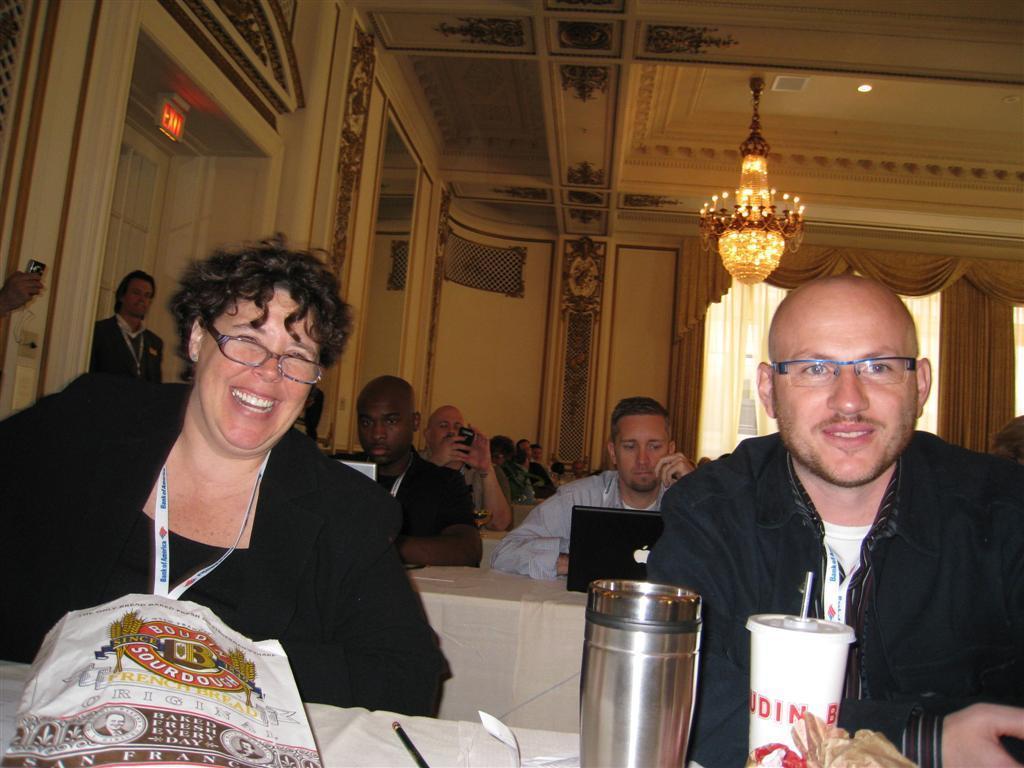In one or two sentences, can you explain what this image depicts? In the picture we can see a man and a woman are sitting near the table, they are in the black dresses, tags and woman is smiling and on the table, we can see a food packet and beside it, we can see some papers and pen on it and beside it we can see the glass with a straw and in the background we can see some people are also sitting near the desks and working on the laptop and beside them, we can see a man standing near the exit door and to the ceiling we can see a Chandelier and the light. 